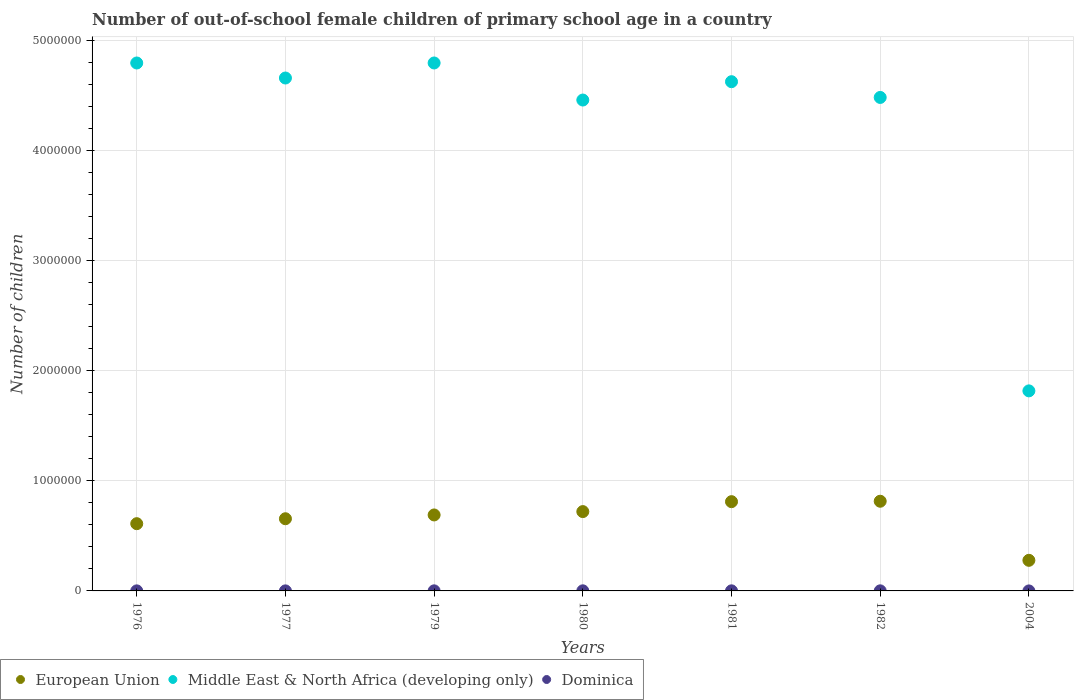Across all years, what is the maximum number of out-of-school female children in Dominica?
Your answer should be very brief. 950. Across all years, what is the minimum number of out-of-school female children in Middle East & North Africa (developing only)?
Your answer should be very brief. 1.82e+06. In which year was the number of out-of-school female children in Dominica maximum?
Offer a terse response. 1980. What is the total number of out-of-school female children in Middle East & North Africa (developing only) in the graph?
Make the answer very short. 2.96e+07. What is the difference between the number of out-of-school female children in European Union in 1979 and that in 1980?
Your answer should be compact. -3.04e+04. What is the difference between the number of out-of-school female children in European Union in 1979 and the number of out-of-school female children in Dominica in 1981?
Offer a terse response. 6.89e+05. What is the average number of out-of-school female children in European Union per year?
Your response must be concise. 6.54e+05. In the year 1976, what is the difference between the number of out-of-school female children in Dominica and number of out-of-school female children in European Union?
Your answer should be compact. -6.10e+05. In how many years, is the number of out-of-school female children in European Union greater than 200000?
Ensure brevity in your answer.  7. What is the ratio of the number of out-of-school female children in Dominica in 1976 to that in 2004?
Keep it short and to the point. 50.2. Is the number of out-of-school female children in Middle East & North Africa (developing only) in 1977 less than that in 2004?
Make the answer very short. No. Is the difference between the number of out-of-school female children in Dominica in 1976 and 1980 greater than the difference between the number of out-of-school female children in European Union in 1976 and 1980?
Provide a short and direct response. Yes. What is the difference between the highest and the second highest number of out-of-school female children in European Union?
Your response must be concise. 3878. What is the difference between the highest and the lowest number of out-of-school female children in Middle East & North Africa (developing only)?
Your response must be concise. 2.98e+06. Is the sum of the number of out-of-school female children in Dominica in 1977 and 1980 greater than the maximum number of out-of-school female children in Middle East & North Africa (developing only) across all years?
Offer a terse response. No. Is it the case that in every year, the sum of the number of out-of-school female children in European Union and number of out-of-school female children in Middle East & North Africa (developing only)  is greater than the number of out-of-school female children in Dominica?
Give a very brief answer. Yes. Does the number of out-of-school female children in European Union monotonically increase over the years?
Give a very brief answer. No. Is the number of out-of-school female children in Middle East & North Africa (developing only) strictly less than the number of out-of-school female children in Dominica over the years?
Offer a very short reply. No. How many years are there in the graph?
Ensure brevity in your answer.  7. Does the graph contain any zero values?
Keep it short and to the point. No. How are the legend labels stacked?
Make the answer very short. Horizontal. What is the title of the graph?
Make the answer very short. Number of out-of-school female children of primary school age in a country. Does "OECD members" appear as one of the legend labels in the graph?
Your answer should be very brief. No. What is the label or title of the X-axis?
Provide a short and direct response. Years. What is the label or title of the Y-axis?
Make the answer very short. Number of children. What is the Number of children of European Union in 1976?
Offer a terse response. 6.11e+05. What is the Number of children in Middle East & North Africa (developing only) in 1976?
Your response must be concise. 4.80e+06. What is the Number of children of Dominica in 1976?
Your answer should be compact. 502. What is the Number of children of European Union in 1977?
Keep it short and to the point. 6.56e+05. What is the Number of children in Middle East & North Africa (developing only) in 1977?
Your answer should be compact. 4.66e+06. What is the Number of children of Dominica in 1977?
Provide a short and direct response. 424. What is the Number of children in European Union in 1979?
Provide a short and direct response. 6.90e+05. What is the Number of children in Middle East & North Africa (developing only) in 1979?
Your answer should be compact. 4.80e+06. What is the Number of children in Dominica in 1979?
Offer a terse response. 743. What is the Number of children of European Union in 1980?
Offer a very short reply. 7.21e+05. What is the Number of children of Middle East & North Africa (developing only) in 1980?
Provide a succinct answer. 4.46e+06. What is the Number of children in Dominica in 1980?
Offer a very short reply. 950. What is the Number of children in European Union in 1981?
Your answer should be very brief. 8.11e+05. What is the Number of children in Middle East & North Africa (developing only) in 1981?
Offer a very short reply. 4.63e+06. What is the Number of children of Dominica in 1981?
Your answer should be compact. 778. What is the Number of children in European Union in 1982?
Provide a succinct answer. 8.15e+05. What is the Number of children of Middle East & North Africa (developing only) in 1982?
Keep it short and to the point. 4.48e+06. What is the Number of children in Dominica in 1982?
Your response must be concise. 780. What is the Number of children of European Union in 2004?
Your answer should be very brief. 2.78e+05. What is the Number of children in Middle East & North Africa (developing only) in 2004?
Offer a terse response. 1.82e+06. Across all years, what is the maximum Number of children of European Union?
Give a very brief answer. 8.15e+05. Across all years, what is the maximum Number of children of Middle East & North Africa (developing only)?
Give a very brief answer. 4.80e+06. Across all years, what is the maximum Number of children of Dominica?
Offer a terse response. 950. Across all years, what is the minimum Number of children in European Union?
Provide a succinct answer. 2.78e+05. Across all years, what is the minimum Number of children in Middle East & North Africa (developing only)?
Offer a very short reply. 1.82e+06. What is the total Number of children in European Union in the graph?
Your response must be concise. 4.58e+06. What is the total Number of children of Middle East & North Africa (developing only) in the graph?
Your response must be concise. 2.96e+07. What is the total Number of children in Dominica in the graph?
Offer a terse response. 4187. What is the difference between the Number of children in European Union in 1976 and that in 1977?
Make the answer very short. -4.49e+04. What is the difference between the Number of children of Middle East & North Africa (developing only) in 1976 and that in 1977?
Ensure brevity in your answer.  1.36e+05. What is the difference between the Number of children in Dominica in 1976 and that in 1977?
Make the answer very short. 78. What is the difference between the Number of children of European Union in 1976 and that in 1979?
Ensure brevity in your answer.  -7.93e+04. What is the difference between the Number of children of Middle East & North Africa (developing only) in 1976 and that in 1979?
Provide a succinct answer. -138. What is the difference between the Number of children in Dominica in 1976 and that in 1979?
Your response must be concise. -241. What is the difference between the Number of children in European Union in 1976 and that in 1980?
Your answer should be compact. -1.10e+05. What is the difference between the Number of children in Middle East & North Africa (developing only) in 1976 and that in 1980?
Your answer should be very brief. 3.37e+05. What is the difference between the Number of children of Dominica in 1976 and that in 1980?
Provide a succinct answer. -448. What is the difference between the Number of children of European Union in 1976 and that in 1981?
Your answer should be compact. -2.00e+05. What is the difference between the Number of children in Middle East & North Africa (developing only) in 1976 and that in 1981?
Offer a terse response. 1.70e+05. What is the difference between the Number of children of Dominica in 1976 and that in 1981?
Make the answer very short. -276. What is the difference between the Number of children of European Union in 1976 and that in 1982?
Your answer should be compact. -2.04e+05. What is the difference between the Number of children of Middle East & North Africa (developing only) in 1976 and that in 1982?
Provide a short and direct response. 3.13e+05. What is the difference between the Number of children of Dominica in 1976 and that in 1982?
Your answer should be compact. -278. What is the difference between the Number of children in European Union in 1976 and that in 2004?
Provide a succinct answer. 3.33e+05. What is the difference between the Number of children of Middle East & North Africa (developing only) in 1976 and that in 2004?
Offer a terse response. 2.98e+06. What is the difference between the Number of children of Dominica in 1976 and that in 2004?
Keep it short and to the point. 492. What is the difference between the Number of children of European Union in 1977 and that in 1979?
Your response must be concise. -3.44e+04. What is the difference between the Number of children of Middle East & North Africa (developing only) in 1977 and that in 1979?
Ensure brevity in your answer.  -1.37e+05. What is the difference between the Number of children of Dominica in 1977 and that in 1979?
Ensure brevity in your answer.  -319. What is the difference between the Number of children in European Union in 1977 and that in 1980?
Your answer should be compact. -6.49e+04. What is the difference between the Number of children in Middle East & North Africa (developing only) in 1977 and that in 1980?
Give a very brief answer. 2.00e+05. What is the difference between the Number of children in Dominica in 1977 and that in 1980?
Offer a very short reply. -526. What is the difference between the Number of children of European Union in 1977 and that in 1981?
Provide a short and direct response. -1.55e+05. What is the difference between the Number of children in Middle East & North Africa (developing only) in 1977 and that in 1981?
Your response must be concise. 3.34e+04. What is the difference between the Number of children in Dominica in 1977 and that in 1981?
Provide a short and direct response. -354. What is the difference between the Number of children in European Union in 1977 and that in 1982?
Keep it short and to the point. -1.59e+05. What is the difference between the Number of children of Middle East & North Africa (developing only) in 1977 and that in 1982?
Provide a short and direct response. 1.76e+05. What is the difference between the Number of children of Dominica in 1977 and that in 1982?
Make the answer very short. -356. What is the difference between the Number of children of European Union in 1977 and that in 2004?
Offer a very short reply. 3.78e+05. What is the difference between the Number of children in Middle East & North Africa (developing only) in 1977 and that in 2004?
Provide a succinct answer. 2.84e+06. What is the difference between the Number of children of Dominica in 1977 and that in 2004?
Provide a succinct answer. 414. What is the difference between the Number of children in European Union in 1979 and that in 1980?
Provide a short and direct response. -3.04e+04. What is the difference between the Number of children of Middle East & North Africa (developing only) in 1979 and that in 1980?
Your answer should be compact. 3.37e+05. What is the difference between the Number of children in Dominica in 1979 and that in 1980?
Provide a short and direct response. -207. What is the difference between the Number of children of European Union in 1979 and that in 1981?
Your response must be concise. -1.21e+05. What is the difference between the Number of children of Middle East & North Africa (developing only) in 1979 and that in 1981?
Provide a succinct answer. 1.70e+05. What is the difference between the Number of children in Dominica in 1979 and that in 1981?
Your answer should be very brief. -35. What is the difference between the Number of children of European Union in 1979 and that in 1982?
Ensure brevity in your answer.  -1.24e+05. What is the difference between the Number of children of Middle East & North Africa (developing only) in 1979 and that in 1982?
Provide a short and direct response. 3.13e+05. What is the difference between the Number of children of Dominica in 1979 and that in 1982?
Make the answer very short. -37. What is the difference between the Number of children in European Union in 1979 and that in 2004?
Give a very brief answer. 4.12e+05. What is the difference between the Number of children in Middle East & North Africa (developing only) in 1979 and that in 2004?
Give a very brief answer. 2.98e+06. What is the difference between the Number of children in Dominica in 1979 and that in 2004?
Ensure brevity in your answer.  733. What is the difference between the Number of children in European Union in 1980 and that in 1981?
Offer a terse response. -9.02e+04. What is the difference between the Number of children in Middle East & North Africa (developing only) in 1980 and that in 1981?
Offer a very short reply. -1.67e+05. What is the difference between the Number of children in Dominica in 1980 and that in 1981?
Ensure brevity in your answer.  172. What is the difference between the Number of children of European Union in 1980 and that in 1982?
Your answer should be very brief. -9.41e+04. What is the difference between the Number of children in Middle East & North Africa (developing only) in 1980 and that in 1982?
Ensure brevity in your answer.  -2.35e+04. What is the difference between the Number of children of Dominica in 1980 and that in 1982?
Keep it short and to the point. 170. What is the difference between the Number of children in European Union in 1980 and that in 2004?
Make the answer very short. 4.43e+05. What is the difference between the Number of children in Middle East & North Africa (developing only) in 1980 and that in 2004?
Your response must be concise. 2.64e+06. What is the difference between the Number of children of Dominica in 1980 and that in 2004?
Offer a terse response. 940. What is the difference between the Number of children of European Union in 1981 and that in 1982?
Your answer should be very brief. -3878. What is the difference between the Number of children in Middle East & North Africa (developing only) in 1981 and that in 1982?
Your answer should be compact. 1.43e+05. What is the difference between the Number of children in European Union in 1981 and that in 2004?
Your response must be concise. 5.33e+05. What is the difference between the Number of children in Middle East & North Africa (developing only) in 1981 and that in 2004?
Give a very brief answer. 2.81e+06. What is the difference between the Number of children of Dominica in 1981 and that in 2004?
Your response must be concise. 768. What is the difference between the Number of children in European Union in 1982 and that in 2004?
Provide a succinct answer. 5.37e+05. What is the difference between the Number of children of Middle East & North Africa (developing only) in 1982 and that in 2004?
Your response must be concise. 2.67e+06. What is the difference between the Number of children of Dominica in 1982 and that in 2004?
Your answer should be compact. 770. What is the difference between the Number of children in European Union in 1976 and the Number of children in Middle East & North Africa (developing only) in 1977?
Offer a very short reply. -4.05e+06. What is the difference between the Number of children of European Union in 1976 and the Number of children of Dominica in 1977?
Your answer should be very brief. 6.10e+05. What is the difference between the Number of children in Middle East & North Africa (developing only) in 1976 and the Number of children in Dominica in 1977?
Ensure brevity in your answer.  4.80e+06. What is the difference between the Number of children in European Union in 1976 and the Number of children in Middle East & North Africa (developing only) in 1979?
Offer a terse response. -4.19e+06. What is the difference between the Number of children in European Union in 1976 and the Number of children in Dominica in 1979?
Give a very brief answer. 6.10e+05. What is the difference between the Number of children in Middle East & North Africa (developing only) in 1976 and the Number of children in Dominica in 1979?
Your answer should be compact. 4.80e+06. What is the difference between the Number of children in European Union in 1976 and the Number of children in Middle East & North Africa (developing only) in 1980?
Provide a succinct answer. -3.85e+06. What is the difference between the Number of children in European Union in 1976 and the Number of children in Dominica in 1980?
Your answer should be very brief. 6.10e+05. What is the difference between the Number of children in Middle East & North Africa (developing only) in 1976 and the Number of children in Dominica in 1980?
Ensure brevity in your answer.  4.79e+06. What is the difference between the Number of children of European Union in 1976 and the Number of children of Middle East & North Africa (developing only) in 1981?
Make the answer very short. -4.02e+06. What is the difference between the Number of children in European Union in 1976 and the Number of children in Dominica in 1981?
Give a very brief answer. 6.10e+05. What is the difference between the Number of children of Middle East & North Africa (developing only) in 1976 and the Number of children of Dominica in 1981?
Your response must be concise. 4.80e+06. What is the difference between the Number of children in European Union in 1976 and the Number of children in Middle East & North Africa (developing only) in 1982?
Your response must be concise. -3.87e+06. What is the difference between the Number of children in European Union in 1976 and the Number of children in Dominica in 1982?
Your answer should be compact. 6.10e+05. What is the difference between the Number of children of Middle East & North Africa (developing only) in 1976 and the Number of children of Dominica in 1982?
Keep it short and to the point. 4.80e+06. What is the difference between the Number of children in European Union in 1976 and the Number of children in Middle East & North Africa (developing only) in 2004?
Give a very brief answer. -1.21e+06. What is the difference between the Number of children in European Union in 1976 and the Number of children in Dominica in 2004?
Your response must be concise. 6.11e+05. What is the difference between the Number of children of Middle East & North Africa (developing only) in 1976 and the Number of children of Dominica in 2004?
Make the answer very short. 4.80e+06. What is the difference between the Number of children in European Union in 1977 and the Number of children in Middle East & North Africa (developing only) in 1979?
Give a very brief answer. -4.14e+06. What is the difference between the Number of children of European Union in 1977 and the Number of children of Dominica in 1979?
Keep it short and to the point. 6.55e+05. What is the difference between the Number of children in Middle East & North Africa (developing only) in 1977 and the Number of children in Dominica in 1979?
Offer a terse response. 4.66e+06. What is the difference between the Number of children in European Union in 1977 and the Number of children in Middle East & North Africa (developing only) in 1980?
Give a very brief answer. -3.80e+06. What is the difference between the Number of children of European Union in 1977 and the Number of children of Dominica in 1980?
Your answer should be very brief. 6.55e+05. What is the difference between the Number of children of Middle East & North Africa (developing only) in 1977 and the Number of children of Dominica in 1980?
Ensure brevity in your answer.  4.66e+06. What is the difference between the Number of children of European Union in 1977 and the Number of children of Middle East & North Africa (developing only) in 1981?
Ensure brevity in your answer.  -3.97e+06. What is the difference between the Number of children of European Union in 1977 and the Number of children of Dominica in 1981?
Keep it short and to the point. 6.55e+05. What is the difference between the Number of children of Middle East & North Africa (developing only) in 1977 and the Number of children of Dominica in 1981?
Ensure brevity in your answer.  4.66e+06. What is the difference between the Number of children in European Union in 1977 and the Number of children in Middle East & North Africa (developing only) in 1982?
Ensure brevity in your answer.  -3.83e+06. What is the difference between the Number of children of European Union in 1977 and the Number of children of Dominica in 1982?
Provide a succinct answer. 6.55e+05. What is the difference between the Number of children of Middle East & North Africa (developing only) in 1977 and the Number of children of Dominica in 1982?
Give a very brief answer. 4.66e+06. What is the difference between the Number of children in European Union in 1977 and the Number of children in Middle East & North Africa (developing only) in 2004?
Keep it short and to the point. -1.16e+06. What is the difference between the Number of children in European Union in 1977 and the Number of children in Dominica in 2004?
Offer a very short reply. 6.56e+05. What is the difference between the Number of children of Middle East & North Africa (developing only) in 1977 and the Number of children of Dominica in 2004?
Your answer should be very brief. 4.66e+06. What is the difference between the Number of children of European Union in 1979 and the Number of children of Middle East & North Africa (developing only) in 1980?
Offer a terse response. -3.77e+06. What is the difference between the Number of children of European Union in 1979 and the Number of children of Dominica in 1980?
Your response must be concise. 6.89e+05. What is the difference between the Number of children in Middle East & North Africa (developing only) in 1979 and the Number of children in Dominica in 1980?
Provide a succinct answer. 4.79e+06. What is the difference between the Number of children in European Union in 1979 and the Number of children in Middle East & North Africa (developing only) in 1981?
Provide a succinct answer. -3.94e+06. What is the difference between the Number of children of European Union in 1979 and the Number of children of Dominica in 1981?
Offer a very short reply. 6.89e+05. What is the difference between the Number of children of Middle East & North Africa (developing only) in 1979 and the Number of children of Dominica in 1981?
Ensure brevity in your answer.  4.80e+06. What is the difference between the Number of children of European Union in 1979 and the Number of children of Middle East & North Africa (developing only) in 1982?
Your answer should be very brief. -3.79e+06. What is the difference between the Number of children of European Union in 1979 and the Number of children of Dominica in 1982?
Give a very brief answer. 6.89e+05. What is the difference between the Number of children in Middle East & North Africa (developing only) in 1979 and the Number of children in Dominica in 1982?
Give a very brief answer. 4.80e+06. What is the difference between the Number of children of European Union in 1979 and the Number of children of Middle East & North Africa (developing only) in 2004?
Your answer should be very brief. -1.13e+06. What is the difference between the Number of children of European Union in 1979 and the Number of children of Dominica in 2004?
Offer a terse response. 6.90e+05. What is the difference between the Number of children of Middle East & North Africa (developing only) in 1979 and the Number of children of Dominica in 2004?
Your answer should be very brief. 4.80e+06. What is the difference between the Number of children of European Union in 1980 and the Number of children of Middle East & North Africa (developing only) in 1981?
Ensure brevity in your answer.  -3.91e+06. What is the difference between the Number of children of European Union in 1980 and the Number of children of Dominica in 1981?
Your answer should be compact. 7.20e+05. What is the difference between the Number of children in Middle East & North Africa (developing only) in 1980 and the Number of children in Dominica in 1981?
Offer a terse response. 4.46e+06. What is the difference between the Number of children in European Union in 1980 and the Number of children in Middle East & North Africa (developing only) in 1982?
Offer a very short reply. -3.76e+06. What is the difference between the Number of children of European Union in 1980 and the Number of children of Dominica in 1982?
Ensure brevity in your answer.  7.20e+05. What is the difference between the Number of children of Middle East & North Africa (developing only) in 1980 and the Number of children of Dominica in 1982?
Offer a very short reply. 4.46e+06. What is the difference between the Number of children of European Union in 1980 and the Number of children of Middle East & North Africa (developing only) in 2004?
Ensure brevity in your answer.  -1.10e+06. What is the difference between the Number of children in European Union in 1980 and the Number of children in Dominica in 2004?
Provide a succinct answer. 7.21e+05. What is the difference between the Number of children in Middle East & North Africa (developing only) in 1980 and the Number of children in Dominica in 2004?
Offer a very short reply. 4.46e+06. What is the difference between the Number of children in European Union in 1981 and the Number of children in Middle East & North Africa (developing only) in 1982?
Your response must be concise. -3.67e+06. What is the difference between the Number of children of European Union in 1981 and the Number of children of Dominica in 1982?
Your response must be concise. 8.10e+05. What is the difference between the Number of children in Middle East & North Africa (developing only) in 1981 and the Number of children in Dominica in 1982?
Your response must be concise. 4.63e+06. What is the difference between the Number of children of European Union in 1981 and the Number of children of Middle East & North Africa (developing only) in 2004?
Make the answer very short. -1.01e+06. What is the difference between the Number of children of European Union in 1981 and the Number of children of Dominica in 2004?
Keep it short and to the point. 8.11e+05. What is the difference between the Number of children in Middle East & North Africa (developing only) in 1981 and the Number of children in Dominica in 2004?
Ensure brevity in your answer.  4.63e+06. What is the difference between the Number of children in European Union in 1982 and the Number of children in Middle East & North Africa (developing only) in 2004?
Ensure brevity in your answer.  -1.00e+06. What is the difference between the Number of children in European Union in 1982 and the Number of children in Dominica in 2004?
Give a very brief answer. 8.15e+05. What is the difference between the Number of children of Middle East & North Africa (developing only) in 1982 and the Number of children of Dominica in 2004?
Make the answer very short. 4.48e+06. What is the average Number of children of European Union per year?
Your answer should be compact. 6.54e+05. What is the average Number of children of Middle East & North Africa (developing only) per year?
Provide a short and direct response. 4.23e+06. What is the average Number of children in Dominica per year?
Your response must be concise. 598.14. In the year 1976, what is the difference between the Number of children of European Union and Number of children of Middle East & North Africa (developing only)?
Your answer should be compact. -4.18e+06. In the year 1976, what is the difference between the Number of children of European Union and Number of children of Dominica?
Ensure brevity in your answer.  6.10e+05. In the year 1976, what is the difference between the Number of children in Middle East & North Africa (developing only) and Number of children in Dominica?
Make the answer very short. 4.80e+06. In the year 1977, what is the difference between the Number of children of European Union and Number of children of Middle East & North Africa (developing only)?
Provide a short and direct response. -4.00e+06. In the year 1977, what is the difference between the Number of children of European Union and Number of children of Dominica?
Provide a succinct answer. 6.55e+05. In the year 1977, what is the difference between the Number of children in Middle East & North Africa (developing only) and Number of children in Dominica?
Keep it short and to the point. 4.66e+06. In the year 1979, what is the difference between the Number of children in European Union and Number of children in Middle East & North Africa (developing only)?
Your answer should be very brief. -4.11e+06. In the year 1979, what is the difference between the Number of children in European Union and Number of children in Dominica?
Keep it short and to the point. 6.89e+05. In the year 1979, what is the difference between the Number of children in Middle East & North Africa (developing only) and Number of children in Dominica?
Ensure brevity in your answer.  4.80e+06. In the year 1980, what is the difference between the Number of children of European Union and Number of children of Middle East & North Africa (developing only)?
Your answer should be very brief. -3.74e+06. In the year 1980, what is the difference between the Number of children in European Union and Number of children in Dominica?
Give a very brief answer. 7.20e+05. In the year 1980, what is the difference between the Number of children in Middle East & North Africa (developing only) and Number of children in Dominica?
Ensure brevity in your answer.  4.46e+06. In the year 1981, what is the difference between the Number of children of European Union and Number of children of Middle East & North Africa (developing only)?
Offer a terse response. -3.82e+06. In the year 1981, what is the difference between the Number of children of European Union and Number of children of Dominica?
Offer a terse response. 8.10e+05. In the year 1981, what is the difference between the Number of children in Middle East & North Africa (developing only) and Number of children in Dominica?
Your answer should be compact. 4.63e+06. In the year 1982, what is the difference between the Number of children of European Union and Number of children of Middle East & North Africa (developing only)?
Give a very brief answer. -3.67e+06. In the year 1982, what is the difference between the Number of children of European Union and Number of children of Dominica?
Your answer should be very brief. 8.14e+05. In the year 1982, what is the difference between the Number of children of Middle East & North Africa (developing only) and Number of children of Dominica?
Your answer should be very brief. 4.48e+06. In the year 2004, what is the difference between the Number of children in European Union and Number of children in Middle East & North Africa (developing only)?
Provide a succinct answer. -1.54e+06. In the year 2004, what is the difference between the Number of children in European Union and Number of children in Dominica?
Your answer should be compact. 2.78e+05. In the year 2004, what is the difference between the Number of children in Middle East & North Africa (developing only) and Number of children in Dominica?
Offer a very short reply. 1.82e+06. What is the ratio of the Number of children in European Union in 1976 to that in 1977?
Make the answer very short. 0.93. What is the ratio of the Number of children in Middle East & North Africa (developing only) in 1976 to that in 1977?
Your response must be concise. 1.03. What is the ratio of the Number of children in Dominica in 1976 to that in 1977?
Offer a very short reply. 1.18. What is the ratio of the Number of children of European Union in 1976 to that in 1979?
Make the answer very short. 0.89. What is the ratio of the Number of children in Dominica in 1976 to that in 1979?
Provide a succinct answer. 0.68. What is the ratio of the Number of children of European Union in 1976 to that in 1980?
Your answer should be very brief. 0.85. What is the ratio of the Number of children of Middle East & North Africa (developing only) in 1976 to that in 1980?
Your response must be concise. 1.08. What is the ratio of the Number of children of Dominica in 1976 to that in 1980?
Your response must be concise. 0.53. What is the ratio of the Number of children of European Union in 1976 to that in 1981?
Provide a short and direct response. 0.75. What is the ratio of the Number of children in Middle East & North Africa (developing only) in 1976 to that in 1981?
Give a very brief answer. 1.04. What is the ratio of the Number of children in Dominica in 1976 to that in 1981?
Make the answer very short. 0.65. What is the ratio of the Number of children in European Union in 1976 to that in 1982?
Your answer should be compact. 0.75. What is the ratio of the Number of children in Middle East & North Africa (developing only) in 1976 to that in 1982?
Your answer should be compact. 1.07. What is the ratio of the Number of children of Dominica in 1976 to that in 1982?
Ensure brevity in your answer.  0.64. What is the ratio of the Number of children in European Union in 1976 to that in 2004?
Keep it short and to the point. 2.2. What is the ratio of the Number of children in Middle East & North Africa (developing only) in 1976 to that in 2004?
Provide a short and direct response. 2.64. What is the ratio of the Number of children in Dominica in 1976 to that in 2004?
Give a very brief answer. 50.2. What is the ratio of the Number of children of European Union in 1977 to that in 1979?
Your answer should be compact. 0.95. What is the ratio of the Number of children in Middle East & North Africa (developing only) in 1977 to that in 1979?
Ensure brevity in your answer.  0.97. What is the ratio of the Number of children of Dominica in 1977 to that in 1979?
Your answer should be compact. 0.57. What is the ratio of the Number of children in European Union in 1977 to that in 1980?
Make the answer very short. 0.91. What is the ratio of the Number of children in Middle East & North Africa (developing only) in 1977 to that in 1980?
Ensure brevity in your answer.  1.04. What is the ratio of the Number of children of Dominica in 1977 to that in 1980?
Make the answer very short. 0.45. What is the ratio of the Number of children in European Union in 1977 to that in 1981?
Ensure brevity in your answer.  0.81. What is the ratio of the Number of children of Middle East & North Africa (developing only) in 1977 to that in 1981?
Offer a terse response. 1.01. What is the ratio of the Number of children of Dominica in 1977 to that in 1981?
Provide a short and direct response. 0.55. What is the ratio of the Number of children of European Union in 1977 to that in 1982?
Make the answer very short. 0.8. What is the ratio of the Number of children of Middle East & North Africa (developing only) in 1977 to that in 1982?
Offer a very short reply. 1.04. What is the ratio of the Number of children of Dominica in 1977 to that in 1982?
Give a very brief answer. 0.54. What is the ratio of the Number of children of European Union in 1977 to that in 2004?
Keep it short and to the point. 2.36. What is the ratio of the Number of children of Middle East & North Africa (developing only) in 1977 to that in 2004?
Keep it short and to the point. 2.56. What is the ratio of the Number of children in Dominica in 1977 to that in 2004?
Your response must be concise. 42.4. What is the ratio of the Number of children of European Union in 1979 to that in 1980?
Offer a terse response. 0.96. What is the ratio of the Number of children of Middle East & North Africa (developing only) in 1979 to that in 1980?
Give a very brief answer. 1.08. What is the ratio of the Number of children of Dominica in 1979 to that in 1980?
Make the answer very short. 0.78. What is the ratio of the Number of children in European Union in 1979 to that in 1981?
Your response must be concise. 0.85. What is the ratio of the Number of children of Middle East & North Africa (developing only) in 1979 to that in 1981?
Make the answer very short. 1.04. What is the ratio of the Number of children in Dominica in 1979 to that in 1981?
Your answer should be compact. 0.95. What is the ratio of the Number of children of European Union in 1979 to that in 1982?
Your answer should be very brief. 0.85. What is the ratio of the Number of children in Middle East & North Africa (developing only) in 1979 to that in 1982?
Ensure brevity in your answer.  1.07. What is the ratio of the Number of children of Dominica in 1979 to that in 1982?
Provide a succinct answer. 0.95. What is the ratio of the Number of children in European Union in 1979 to that in 2004?
Give a very brief answer. 2.48. What is the ratio of the Number of children in Middle East & North Africa (developing only) in 1979 to that in 2004?
Provide a succinct answer. 2.64. What is the ratio of the Number of children in Dominica in 1979 to that in 2004?
Provide a succinct answer. 74.3. What is the ratio of the Number of children in European Union in 1980 to that in 1981?
Give a very brief answer. 0.89. What is the ratio of the Number of children of Middle East & North Africa (developing only) in 1980 to that in 1981?
Offer a very short reply. 0.96. What is the ratio of the Number of children of Dominica in 1980 to that in 1981?
Your answer should be very brief. 1.22. What is the ratio of the Number of children in European Union in 1980 to that in 1982?
Ensure brevity in your answer.  0.88. What is the ratio of the Number of children of Dominica in 1980 to that in 1982?
Your response must be concise. 1.22. What is the ratio of the Number of children in European Union in 1980 to that in 2004?
Offer a terse response. 2.59. What is the ratio of the Number of children of Middle East & North Africa (developing only) in 1980 to that in 2004?
Ensure brevity in your answer.  2.45. What is the ratio of the Number of children in Dominica in 1980 to that in 2004?
Your answer should be compact. 95. What is the ratio of the Number of children in European Union in 1981 to that in 1982?
Provide a succinct answer. 1. What is the ratio of the Number of children in Middle East & North Africa (developing only) in 1981 to that in 1982?
Your answer should be compact. 1.03. What is the ratio of the Number of children of Dominica in 1981 to that in 1982?
Make the answer very short. 1. What is the ratio of the Number of children in European Union in 1981 to that in 2004?
Provide a succinct answer. 2.92. What is the ratio of the Number of children in Middle East & North Africa (developing only) in 1981 to that in 2004?
Make the answer very short. 2.55. What is the ratio of the Number of children of Dominica in 1981 to that in 2004?
Keep it short and to the point. 77.8. What is the ratio of the Number of children in European Union in 1982 to that in 2004?
Offer a terse response. 2.93. What is the ratio of the Number of children in Middle East & North Africa (developing only) in 1982 to that in 2004?
Give a very brief answer. 2.47. What is the difference between the highest and the second highest Number of children of European Union?
Your response must be concise. 3878. What is the difference between the highest and the second highest Number of children in Middle East & North Africa (developing only)?
Provide a short and direct response. 138. What is the difference between the highest and the second highest Number of children in Dominica?
Your response must be concise. 170. What is the difference between the highest and the lowest Number of children in European Union?
Provide a short and direct response. 5.37e+05. What is the difference between the highest and the lowest Number of children in Middle East & North Africa (developing only)?
Your answer should be very brief. 2.98e+06. What is the difference between the highest and the lowest Number of children of Dominica?
Provide a short and direct response. 940. 